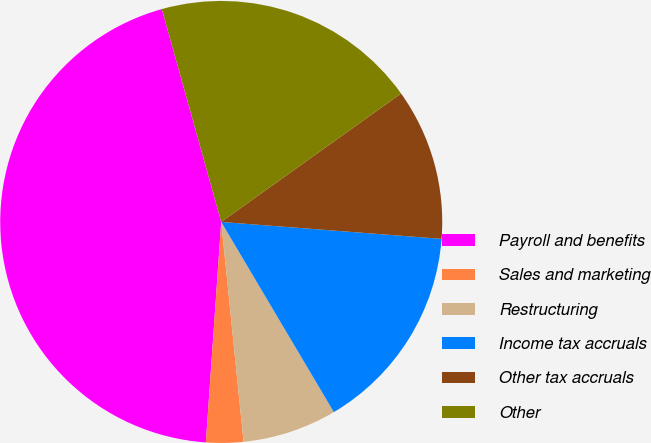Convert chart to OTSL. <chart><loc_0><loc_0><loc_500><loc_500><pie_chart><fcel>Payroll and benefits<fcel>Sales and marketing<fcel>Restructuring<fcel>Income tax accruals<fcel>Other tax accruals<fcel>Other<nl><fcel>44.56%<fcel>2.72%<fcel>6.9%<fcel>15.27%<fcel>11.09%<fcel>19.46%<nl></chart> 